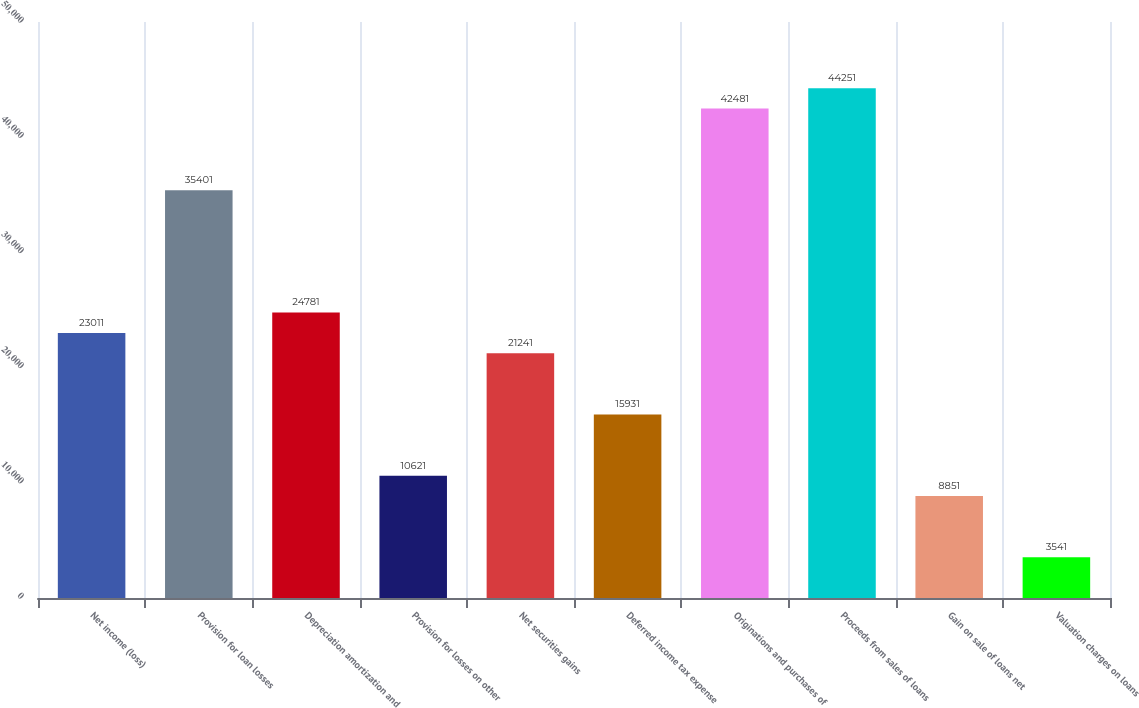<chart> <loc_0><loc_0><loc_500><loc_500><bar_chart><fcel>Net income (loss)<fcel>Provision for loan losses<fcel>Depreciation amortization and<fcel>Provision for losses on other<fcel>Net securities gains<fcel>Deferred income tax expense<fcel>Originations and purchases of<fcel>Proceeds from sales of loans<fcel>Gain on sale of loans net<fcel>Valuation charges on loans<nl><fcel>23011<fcel>35401<fcel>24781<fcel>10621<fcel>21241<fcel>15931<fcel>42481<fcel>44251<fcel>8851<fcel>3541<nl></chart> 